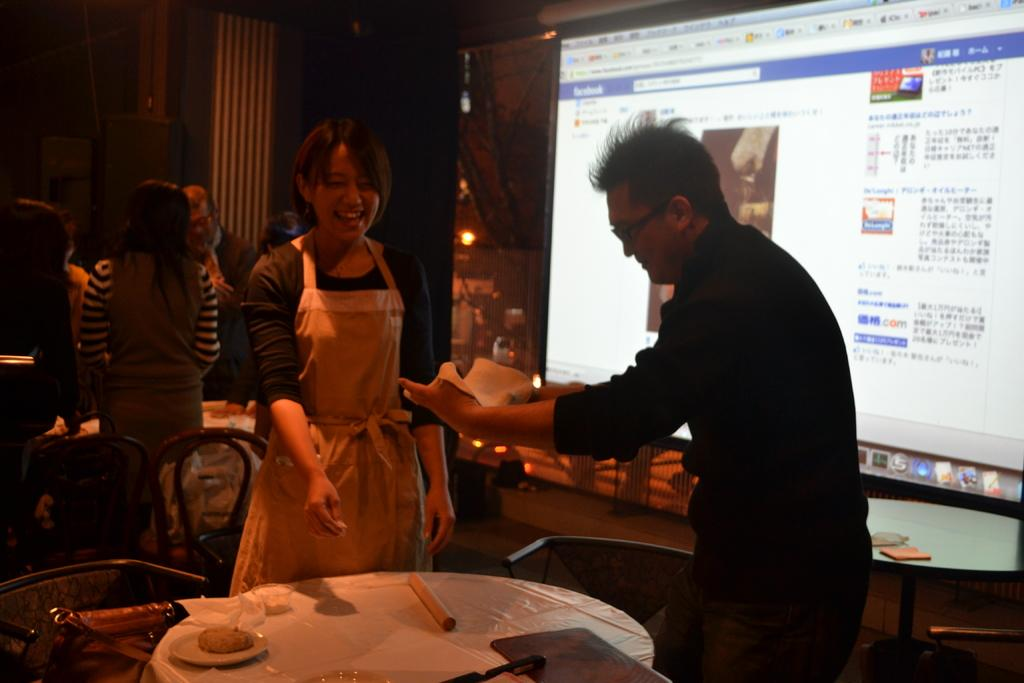What is happening in the image? There are people standing in the image. What can be seen on the screen in the image? Unfortunately, we cannot determine what is on the screen from the given facts. Can you describe the people in the image? We do not have enough information to describe the people in the image. What type of suit is the trouble wearing in the image? There is no person wearing a suit or experiencing trouble in the image. 